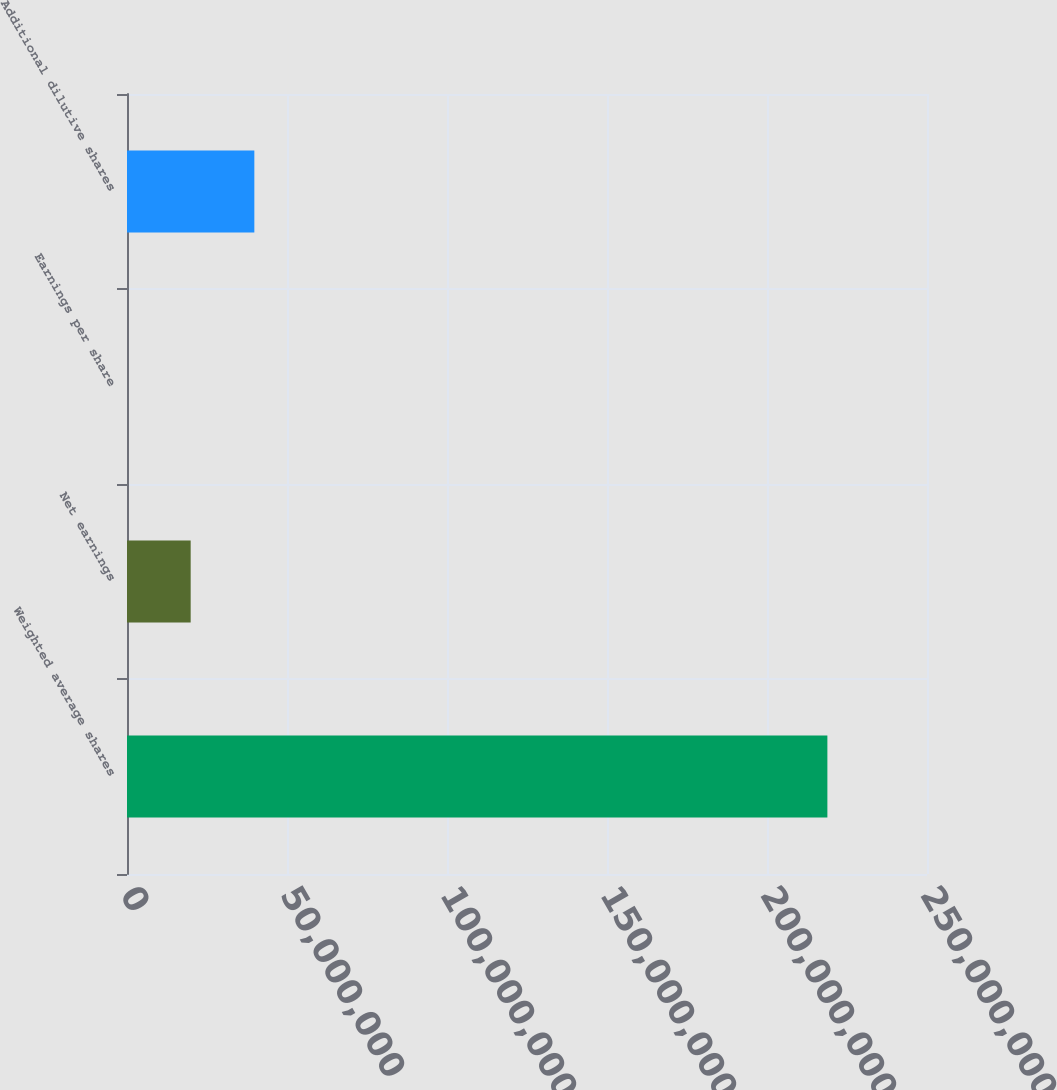Convert chart. <chart><loc_0><loc_0><loc_500><loc_500><bar_chart><fcel>Weighted average shares<fcel>Net earnings<fcel>Earnings per share<fcel>Additional dilutive shares<nl><fcel>2.18869e+08<fcel>1.98971e+07<fcel>1.17<fcel>3.97943e+07<nl></chart> 